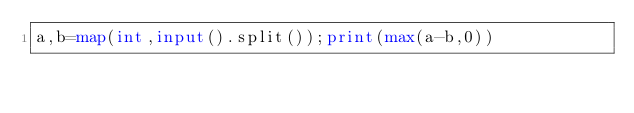<code> <loc_0><loc_0><loc_500><loc_500><_Python_>a,b=map(int,input().split());print(max(a-b,0))</code> 